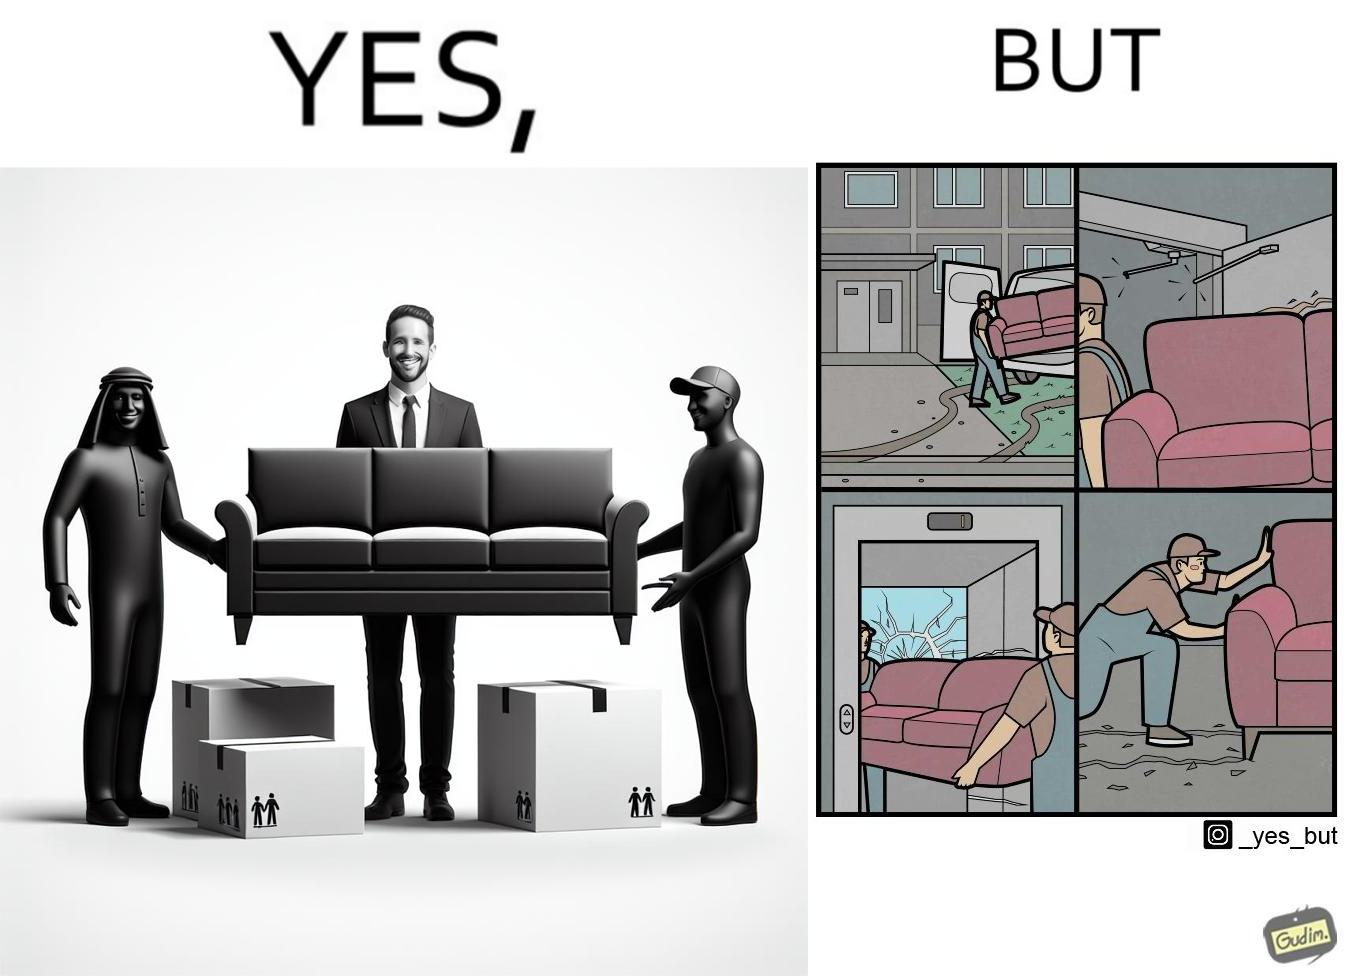Would you classify this image as satirical? Yes, this image is satirical. 